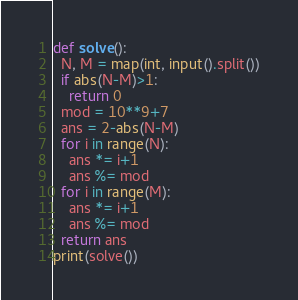<code> <loc_0><loc_0><loc_500><loc_500><_Python_>def solve():
  N, M = map(int, input().split())
  if abs(N-M)>1:
    return 0
  mod = 10**9+7
  ans = 2-abs(N-M)
  for i in range(N):
    ans *= i+1
    ans %= mod
  for i in range(M):
    ans *= i+1
    ans %= mod
  return ans
print(solve())</code> 